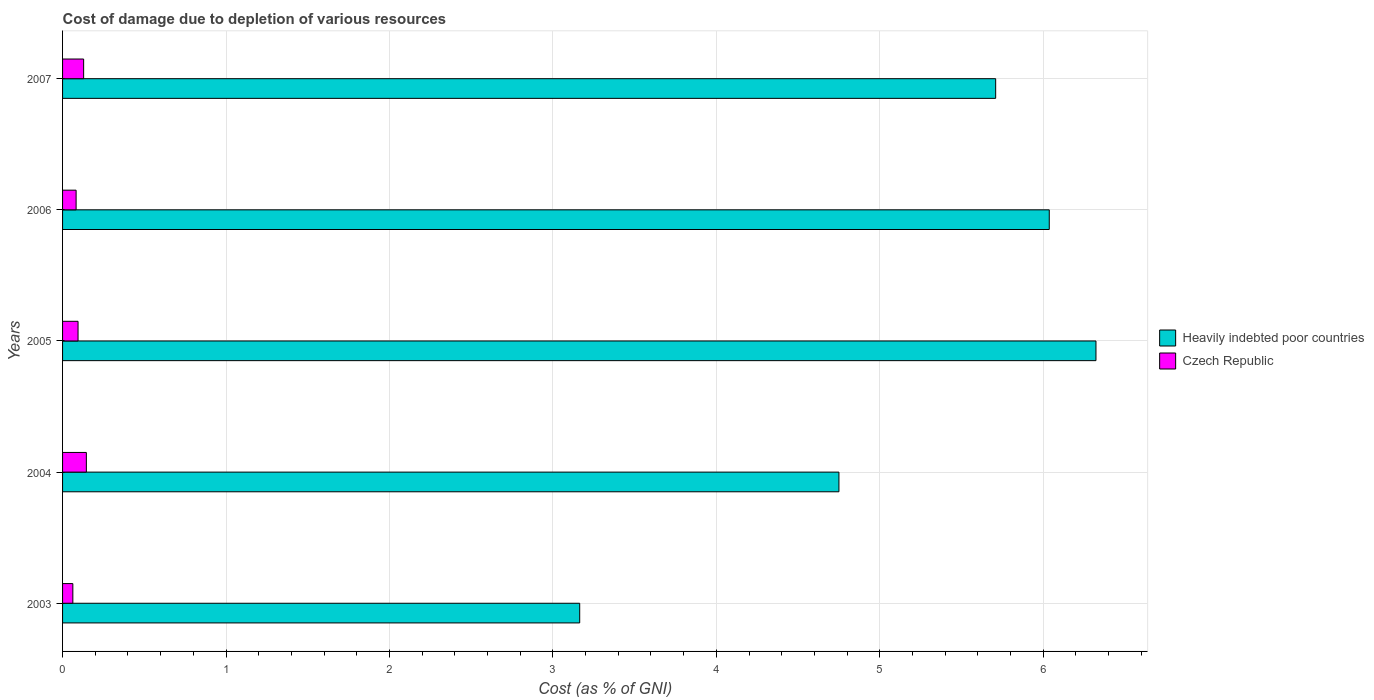How many groups of bars are there?
Provide a succinct answer. 5. How many bars are there on the 5th tick from the bottom?
Your answer should be compact. 2. In how many cases, is the number of bars for a given year not equal to the number of legend labels?
Provide a succinct answer. 0. What is the cost of damage caused due to the depletion of various resources in Heavily indebted poor countries in 2006?
Ensure brevity in your answer.  6.04. Across all years, what is the maximum cost of damage caused due to the depletion of various resources in Heavily indebted poor countries?
Offer a terse response. 6.32. Across all years, what is the minimum cost of damage caused due to the depletion of various resources in Heavily indebted poor countries?
Provide a succinct answer. 3.16. What is the total cost of damage caused due to the depletion of various resources in Czech Republic in the graph?
Offer a terse response. 0.52. What is the difference between the cost of damage caused due to the depletion of various resources in Czech Republic in 2003 and that in 2004?
Your answer should be very brief. -0.08. What is the difference between the cost of damage caused due to the depletion of various resources in Czech Republic in 2004 and the cost of damage caused due to the depletion of various resources in Heavily indebted poor countries in 2005?
Provide a succinct answer. -6.18. What is the average cost of damage caused due to the depletion of various resources in Czech Republic per year?
Provide a short and direct response. 0.1. In the year 2003, what is the difference between the cost of damage caused due to the depletion of various resources in Heavily indebted poor countries and cost of damage caused due to the depletion of various resources in Czech Republic?
Give a very brief answer. 3.1. What is the ratio of the cost of damage caused due to the depletion of various resources in Heavily indebted poor countries in 2004 to that in 2006?
Ensure brevity in your answer.  0.79. Is the cost of damage caused due to the depletion of various resources in Heavily indebted poor countries in 2005 less than that in 2006?
Offer a terse response. No. Is the difference between the cost of damage caused due to the depletion of various resources in Heavily indebted poor countries in 2006 and 2007 greater than the difference between the cost of damage caused due to the depletion of various resources in Czech Republic in 2006 and 2007?
Your answer should be compact. Yes. What is the difference between the highest and the second highest cost of damage caused due to the depletion of various resources in Heavily indebted poor countries?
Make the answer very short. 0.29. What is the difference between the highest and the lowest cost of damage caused due to the depletion of various resources in Heavily indebted poor countries?
Keep it short and to the point. 3.16. In how many years, is the cost of damage caused due to the depletion of various resources in Czech Republic greater than the average cost of damage caused due to the depletion of various resources in Czech Republic taken over all years?
Provide a short and direct response. 2. What does the 1st bar from the top in 2005 represents?
Offer a terse response. Czech Republic. What does the 1st bar from the bottom in 2007 represents?
Ensure brevity in your answer.  Heavily indebted poor countries. How many bars are there?
Your answer should be very brief. 10. Does the graph contain grids?
Keep it short and to the point. Yes. Where does the legend appear in the graph?
Your answer should be compact. Center right. How many legend labels are there?
Your answer should be very brief. 2. What is the title of the graph?
Offer a terse response. Cost of damage due to depletion of various resources. What is the label or title of the X-axis?
Your response must be concise. Cost (as % of GNI). What is the label or title of the Y-axis?
Give a very brief answer. Years. What is the Cost (as % of GNI) in Heavily indebted poor countries in 2003?
Your response must be concise. 3.16. What is the Cost (as % of GNI) of Czech Republic in 2003?
Keep it short and to the point. 0.06. What is the Cost (as % of GNI) of Heavily indebted poor countries in 2004?
Offer a very short reply. 4.75. What is the Cost (as % of GNI) of Czech Republic in 2004?
Provide a short and direct response. 0.15. What is the Cost (as % of GNI) in Heavily indebted poor countries in 2005?
Your answer should be compact. 6.32. What is the Cost (as % of GNI) of Czech Republic in 2005?
Offer a very short reply. 0.09. What is the Cost (as % of GNI) in Heavily indebted poor countries in 2006?
Ensure brevity in your answer.  6.04. What is the Cost (as % of GNI) of Czech Republic in 2006?
Offer a terse response. 0.08. What is the Cost (as % of GNI) of Heavily indebted poor countries in 2007?
Make the answer very short. 5.71. What is the Cost (as % of GNI) of Czech Republic in 2007?
Offer a terse response. 0.13. Across all years, what is the maximum Cost (as % of GNI) of Heavily indebted poor countries?
Make the answer very short. 6.32. Across all years, what is the maximum Cost (as % of GNI) in Czech Republic?
Keep it short and to the point. 0.15. Across all years, what is the minimum Cost (as % of GNI) of Heavily indebted poor countries?
Make the answer very short. 3.16. Across all years, what is the minimum Cost (as % of GNI) in Czech Republic?
Your answer should be very brief. 0.06. What is the total Cost (as % of GNI) in Heavily indebted poor countries in the graph?
Your answer should be compact. 25.98. What is the total Cost (as % of GNI) in Czech Republic in the graph?
Your answer should be compact. 0.52. What is the difference between the Cost (as % of GNI) in Heavily indebted poor countries in 2003 and that in 2004?
Your answer should be very brief. -1.59. What is the difference between the Cost (as % of GNI) of Czech Republic in 2003 and that in 2004?
Your response must be concise. -0.08. What is the difference between the Cost (as % of GNI) of Heavily indebted poor countries in 2003 and that in 2005?
Ensure brevity in your answer.  -3.16. What is the difference between the Cost (as % of GNI) of Czech Republic in 2003 and that in 2005?
Provide a succinct answer. -0.03. What is the difference between the Cost (as % of GNI) of Heavily indebted poor countries in 2003 and that in 2006?
Offer a very short reply. -2.87. What is the difference between the Cost (as % of GNI) in Czech Republic in 2003 and that in 2006?
Offer a very short reply. -0.02. What is the difference between the Cost (as % of GNI) of Heavily indebted poor countries in 2003 and that in 2007?
Make the answer very short. -2.55. What is the difference between the Cost (as % of GNI) in Czech Republic in 2003 and that in 2007?
Your answer should be very brief. -0.07. What is the difference between the Cost (as % of GNI) in Heavily indebted poor countries in 2004 and that in 2005?
Make the answer very short. -1.57. What is the difference between the Cost (as % of GNI) in Czech Republic in 2004 and that in 2005?
Give a very brief answer. 0.05. What is the difference between the Cost (as % of GNI) in Heavily indebted poor countries in 2004 and that in 2006?
Offer a very short reply. -1.29. What is the difference between the Cost (as % of GNI) of Czech Republic in 2004 and that in 2006?
Keep it short and to the point. 0.06. What is the difference between the Cost (as % of GNI) of Heavily indebted poor countries in 2004 and that in 2007?
Ensure brevity in your answer.  -0.96. What is the difference between the Cost (as % of GNI) in Czech Republic in 2004 and that in 2007?
Your response must be concise. 0.02. What is the difference between the Cost (as % of GNI) in Heavily indebted poor countries in 2005 and that in 2006?
Offer a terse response. 0.29. What is the difference between the Cost (as % of GNI) of Czech Republic in 2005 and that in 2006?
Provide a succinct answer. 0.01. What is the difference between the Cost (as % of GNI) in Heavily indebted poor countries in 2005 and that in 2007?
Ensure brevity in your answer.  0.61. What is the difference between the Cost (as % of GNI) in Czech Republic in 2005 and that in 2007?
Provide a short and direct response. -0.03. What is the difference between the Cost (as % of GNI) in Heavily indebted poor countries in 2006 and that in 2007?
Your response must be concise. 0.33. What is the difference between the Cost (as % of GNI) of Czech Republic in 2006 and that in 2007?
Provide a succinct answer. -0.05. What is the difference between the Cost (as % of GNI) of Heavily indebted poor countries in 2003 and the Cost (as % of GNI) of Czech Republic in 2004?
Provide a short and direct response. 3.02. What is the difference between the Cost (as % of GNI) in Heavily indebted poor countries in 2003 and the Cost (as % of GNI) in Czech Republic in 2005?
Keep it short and to the point. 3.07. What is the difference between the Cost (as % of GNI) of Heavily indebted poor countries in 2003 and the Cost (as % of GNI) of Czech Republic in 2006?
Provide a short and direct response. 3.08. What is the difference between the Cost (as % of GNI) of Heavily indebted poor countries in 2003 and the Cost (as % of GNI) of Czech Republic in 2007?
Keep it short and to the point. 3.04. What is the difference between the Cost (as % of GNI) in Heavily indebted poor countries in 2004 and the Cost (as % of GNI) in Czech Republic in 2005?
Offer a terse response. 4.66. What is the difference between the Cost (as % of GNI) of Heavily indebted poor countries in 2004 and the Cost (as % of GNI) of Czech Republic in 2006?
Provide a succinct answer. 4.67. What is the difference between the Cost (as % of GNI) of Heavily indebted poor countries in 2004 and the Cost (as % of GNI) of Czech Republic in 2007?
Make the answer very short. 4.62. What is the difference between the Cost (as % of GNI) in Heavily indebted poor countries in 2005 and the Cost (as % of GNI) in Czech Republic in 2006?
Keep it short and to the point. 6.24. What is the difference between the Cost (as % of GNI) in Heavily indebted poor countries in 2005 and the Cost (as % of GNI) in Czech Republic in 2007?
Ensure brevity in your answer.  6.19. What is the difference between the Cost (as % of GNI) of Heavily indebted poor countries in 2006 and the Cost (as % of GNI) of Czech Republic in 2007?
Keep it short and to the point. 5.91. What is the average Cost (as % of GNI) of Heavily indebted poor countries per year?
Give a very brief answer. 5.2. What is the average Cost (as % of GNI) of Czech Republic per year?
Keep it short and to the point. 0.1. In the year 2003, what is the difference between the Cost (as % of GNI) of Heavily indebted poor countries and Cost (as % of GNI) of Czech Republic?
Make the answer very short. 3.1. In the year 2004, what is the difference between the Cost (as % of GNI) of Heavily indebted poor countries and Cost (as % of GNI) of Czech Republic?
Your response must be concise. 4.6. In the year 2005, what is the difference between the Cost (as % of GNI) of Heavily indebted poor countries and Cost (as % of GNI) of Czech Republic?
Give a very brief answer. 6.23. In the year 2006, what is the difference between the Cost (as % of GNI) of Heavily indebted poor countries and Cost (as % of GNI) of Czech Republic?
Provide a succinct answer. 5.95. In the year 2007, what is the difference between the Cost (as % of GNI) of Heavily indebted poor countries and Cost (as % of GNI) of Czech Republic?
Ensure brevity in your answer.  5.58. What is the ratio of the Cost (as % of GNI) of Heavily indebted poor countries in 2003 to that in 2004?
Offer a terse response. 0.67. What is the ratio of the Cost (as % of GNI) of Czech Republic in 2003 to that in 2004?
Ensure brevity in your answer.  0.43. What is the ratio of the Cost (as % of GNI) in Heavily indebted poor countries in 2003 to that in 2005?
Your answer should be very brief. 0.5. What is the ratio of the Cost (as % of GNI) in Czech Republic in 2003 to that in 2005?
Make the answer very short. 0.66. What is the ratio of the Cost (as % of GNI) in Heavily indebted poor countries in 2003 to that in 2006?
Give a very brief answer. 0.52. What is the ratio of the Cost (as % of GNI) in Czech Republic in 2003 to that in 2006?
Your answer should be compact. 0.76. What is the ratio of the Cost (as % of GNI) in Heavily indebted poor countries in 2003 to that in 2007?
Offer a terse response. 0.55. What is the ratio of the Cost (as % of GNI) of Czech Republic in 2003 to that in 2007?
Give a very brief answer. 0.49. What is the ratio of the Cost (as % of GNI) in Heavily indebted poor countries in 2004 to that in 2005?
Keep it short and to the point. 0.75. What is the ratio of the Cost (as % of GNI) of Czech Republic in 2004 to that in 2005?
Your answer should be very brief. 1.54. What is the ratio of the Cost (as % of GNI) in Heavily indebted poor countries in 2004 to that in 2006?
Give a very brief answer. 0.79. What is the ratio of the Cost (as % of GNI) in Czech Republic in 2004 to that in 2006?
Provide a succinct answer. 1.76. What is the ratio of the Cost (as % of GNI) of Heavily indebted poor countries in 2004 to that in 2007?
Offer a terse response. 0.83. What is the ratio of the Cost (as % of GNI) in Czech Republic in 2004 to that in 2007?
Ensure brevity in your answer.  1.13. What is the ratio of the Cost (as % of GNI) of Heavily indebted poor countries in 2005 to that in 2006?
Ensure brevity in your answer.  1.05. What is the ratio of the Cost (as % of GNI) of Czech Republic in 2005 to that in 2006?
Your answer should be very brief. 1.14. What is the ratio of the Cost (as % of GNI) of Heavily indebted poor countries in 2005 to that in 2007?
Give a very brief answer. 1.11. What is the ratio of the Cost (as % of GNI) of Czech Republic in 2005 to that in 2007?
Your answer should be compact. 0.73. What is the ratio of the Cost (as % of GNI) of Heavily indebted poor countries in 2006 to that in 2007?
Your answer should be very brief. 1.06. What is the ratio of the Cost (as % of GNI) of Czech Republic in 2006 to that in 2007?
Make the answer very short. 0.64. What is the difference between the highest and the second highest Cost (as % of GNI) of Heavily indebted poor countries?
Ensure brevity in your answer.  0.29. What is the difference between the highest and the second highest Cost (as % of GNI) in Czech Republic?
Provide a short and direct response. 0.02. What is the difference between the highest and the lowest Cost (as % of GNI) of Heavily indebted poor countries?
Make the answer very short. 3.16. What is the difference between the highest and the lowest Cost (as % of GNI) of Czech Republic?
Your answer should be compact. 0.08. 